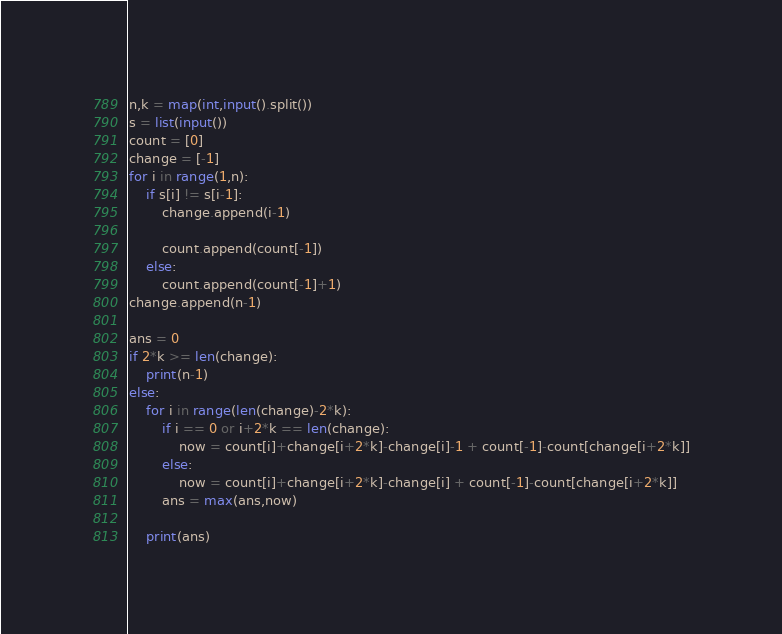<code> <loc_0><loc_0><loc_500><loc_500><_Python_>n,k = map(int,input().split())
s = list(input())
count = [0]
change = [-1]
for i in range(1,n):
    if s[i] != s[i-1]:
        change.append(i-1)
        
        count.append(count[-1])
    else:
        count.append(count[-1]+1)
change.append(n-1)

ans = 0
if 2*k >= len(change):
    print(n-1)
else:
    for i in range(len(change)-2*k):
        if i == 0 or i+2*k == len(change):
            now = count[i]+change[i+2*k]-change[i]-1 + count[-1]-count[change[i+2*k]]
        else:
            now = count[i]+change[i+2*k]-change[i] + count[-1]-count[change[i+2*k]]
        ans = max(ans,now)
        
    print(ans)  
</code> 